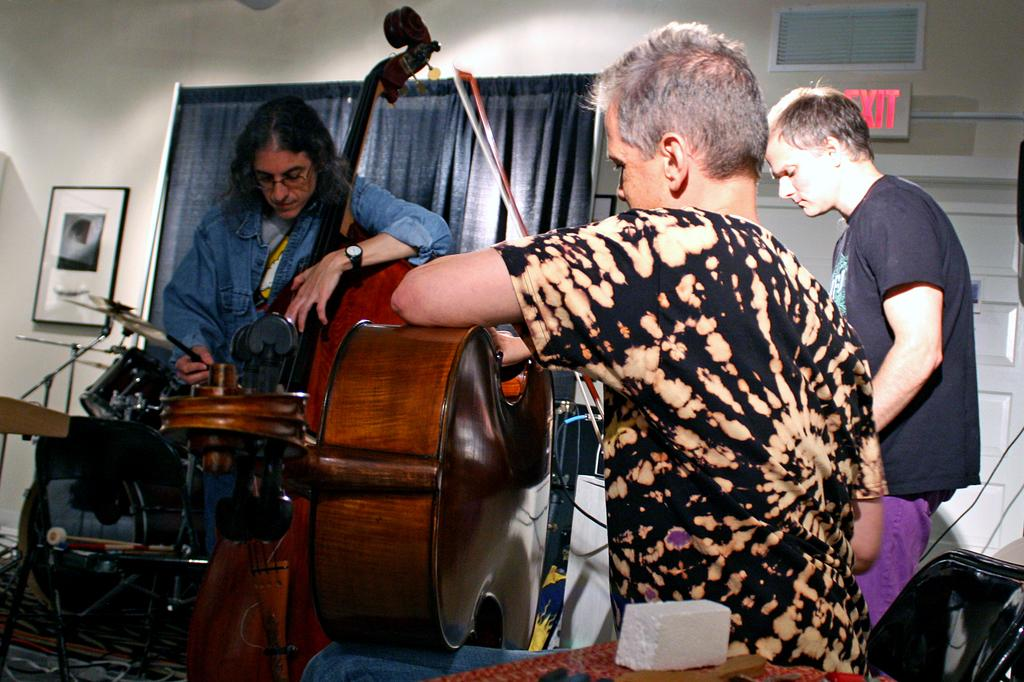What is happening with the group of people in the image? The people are standing and playing guitar in the image. What object is in front of the people? There is a microphone in front of the people. What can be seen in the background of the image? There is a curtain in the image. Is there any other notable feature on the wall in the image? Yes, there is a photo on a wall in the image. Can you see any hills in the background of the image? There are no hills visible in the background of the image. 